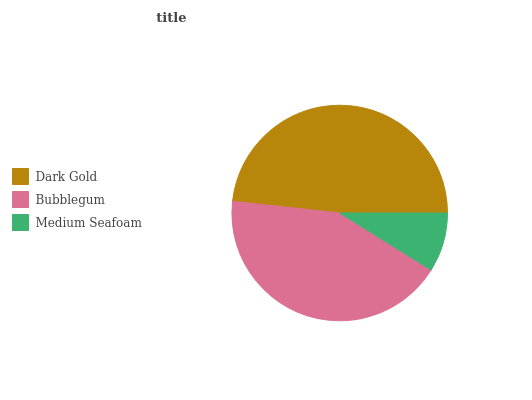Is Medium Seafoam the minimum?
Answer yes or no. Yes. Is Dark Gold the maximum?
Answer yes or no. Yes. Is Bubblegum the minimum?
Answer yes or no. No. Is Bubblegum the maximum?
Answer yes or no. No. Is Dark Gold greater than Bubblegum?
Answer yes or no. Yes. Is Bubblegum less than Dark Gold?
Answer yes or no. Yes. Is Bubblegum greater than Dark Gold?
Answer yes or no. No. Is Dark Gold less than Bubblegum?
Answer yes or no. No. Is Bubblegum the high median?
Answer yes or no. Yes. Is Bubblegum the low median?
Answer yes or no. Yes. Is Dark Gold the high median?
Answer yes or no. No. Is Medium Seafoam the low median?
Answer yes or no. No. 